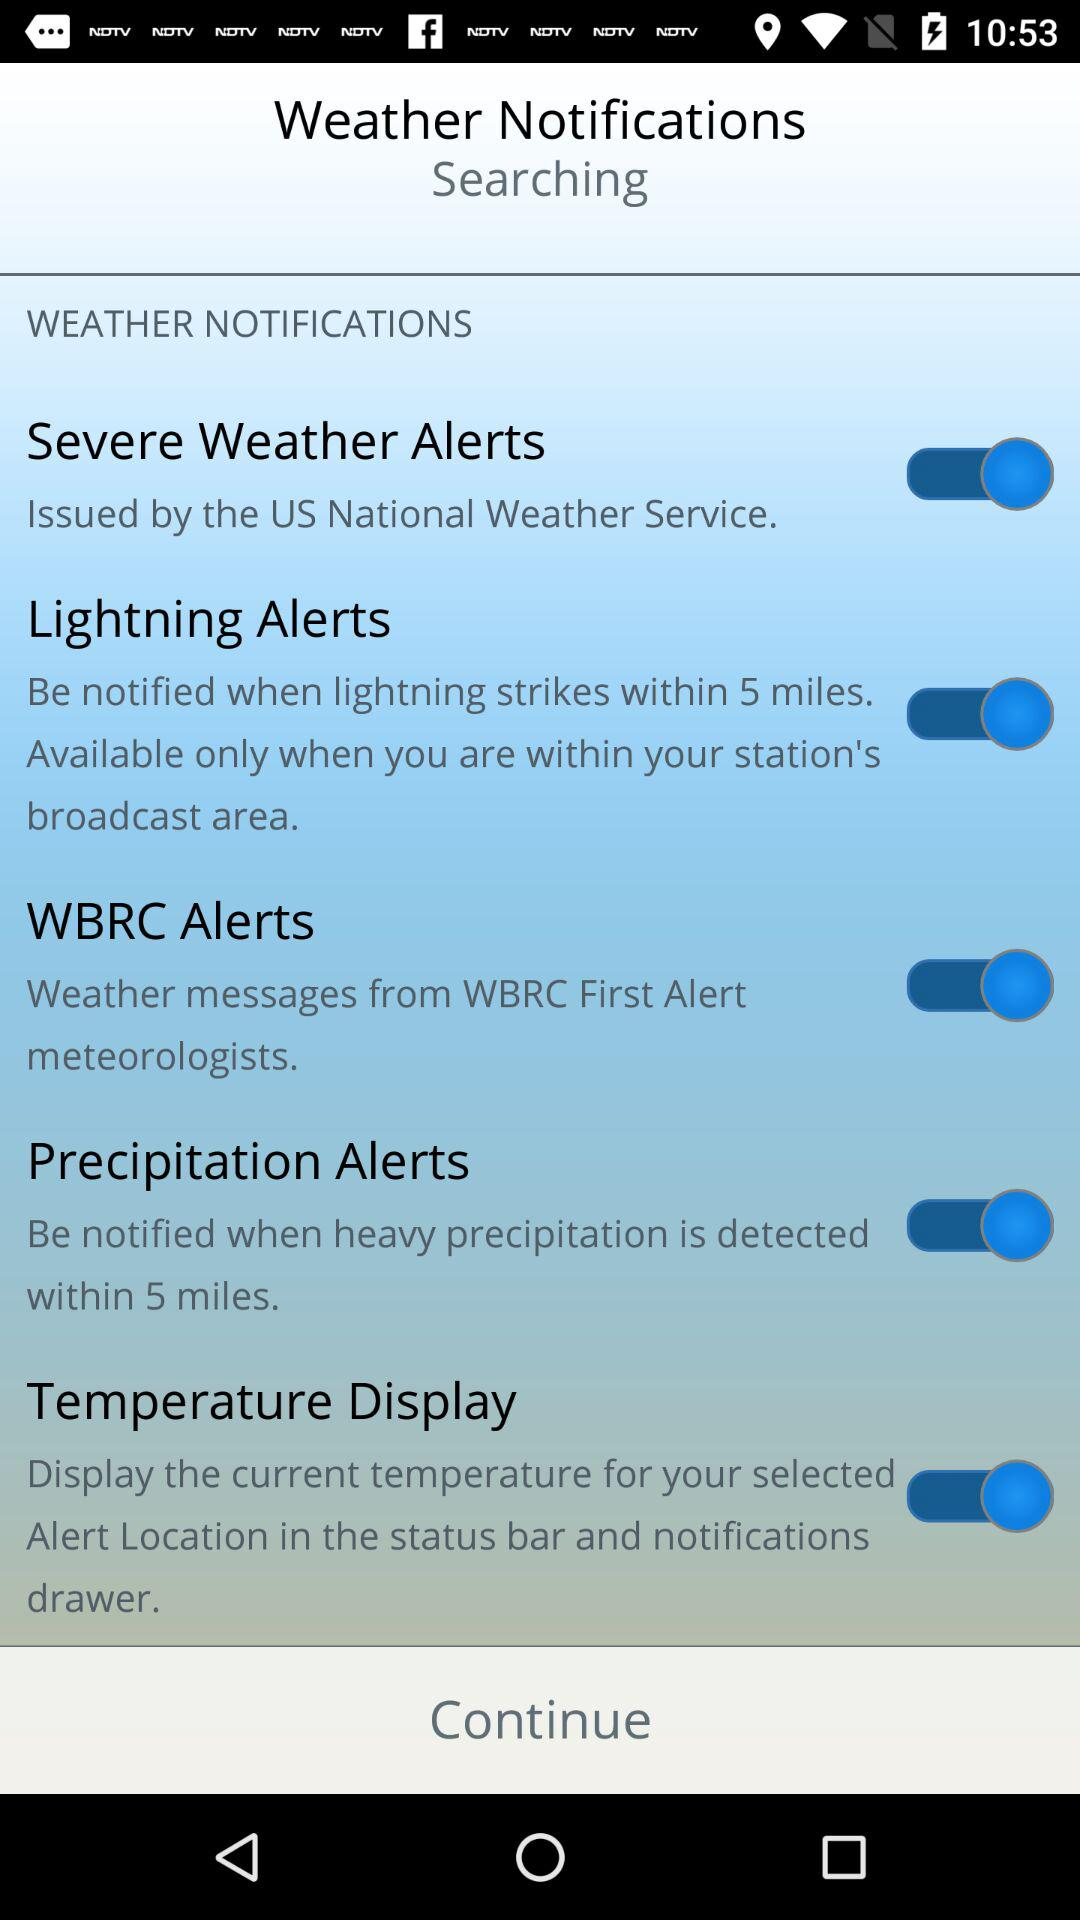What is the current state of WBRC Alerts? The status is "on". 